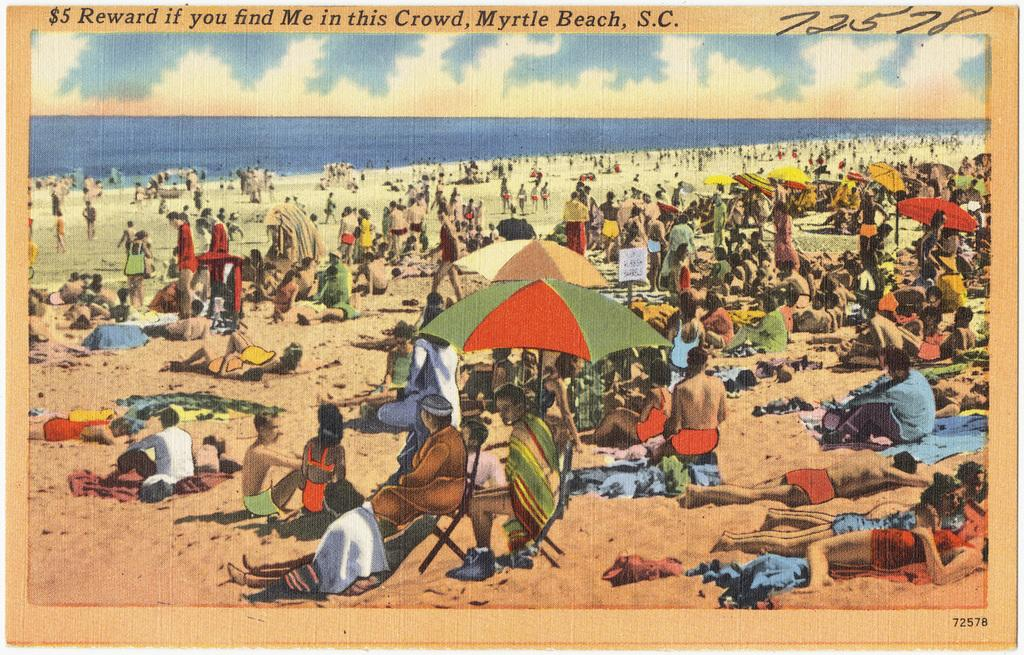<image>
Share a concise interpretation of the image provided. A crowded beach scene postcard from Myrtle Beach, South Carolina. 